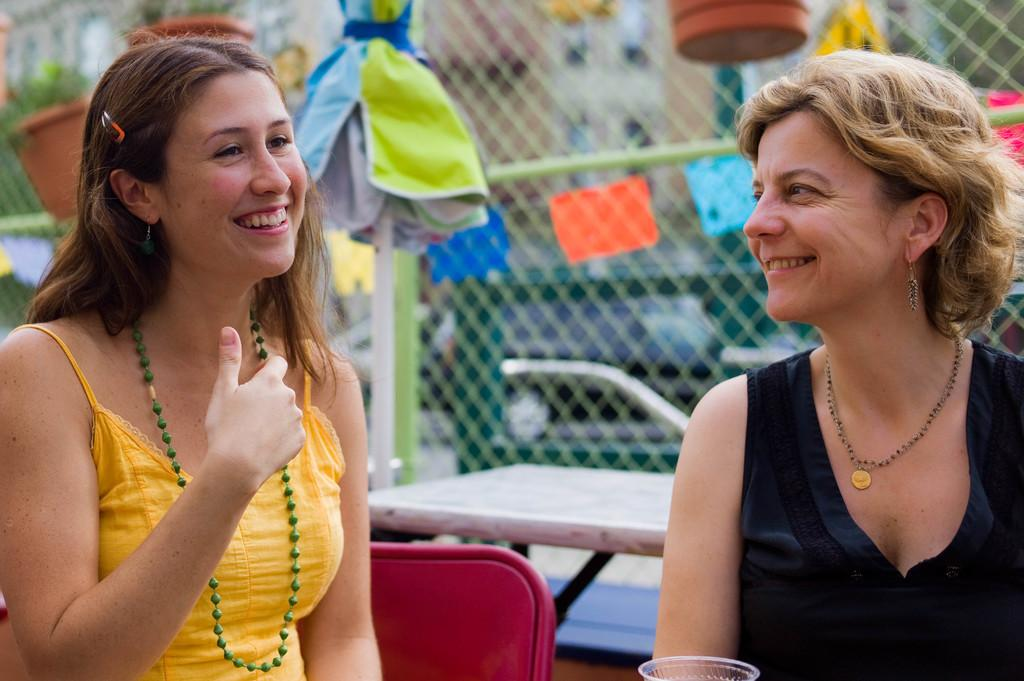How many people are sitting in the image? There are two persons sitting in the image. What is the facial expression of the persons? The persons are smiling. What type of furniture is present in the image? There is a chair and a table in the image. What type of barrier is visible in the image? There is a wire fence in the image. What type of vegetation is present in the image? There are plants in the image. What type of shelter is present in the image? There is an umbrella attached to a pole in the image. What type of structures are visible in the image? There are buildings in the image. What type of transportation is visible in the image? There are vehicles in the image. What type of jam is being spread on the hand in the image? There is no jam or hand present in the image. How many flies can be seen buzzing around the umbrella in the image? There are no flies present in the image. 